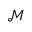<formula> <loc_0><loc_0><loc_500><loc_500>\mathcal { M }</formula> 